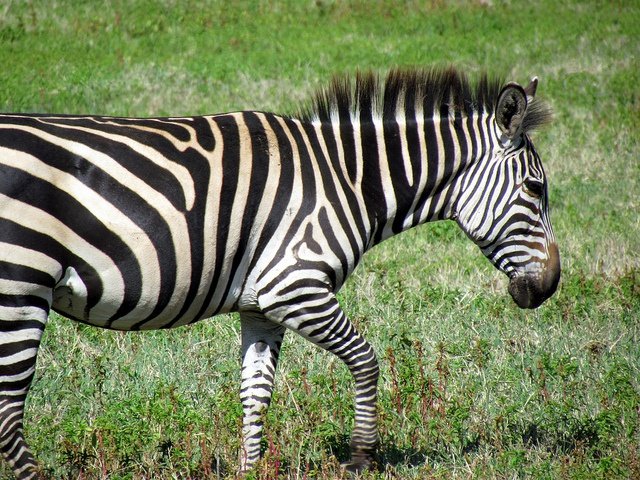Describe the objects in this image and their specific colors. I can see a zebra in olive, black, ivory, gray, and beige tones in this image. 